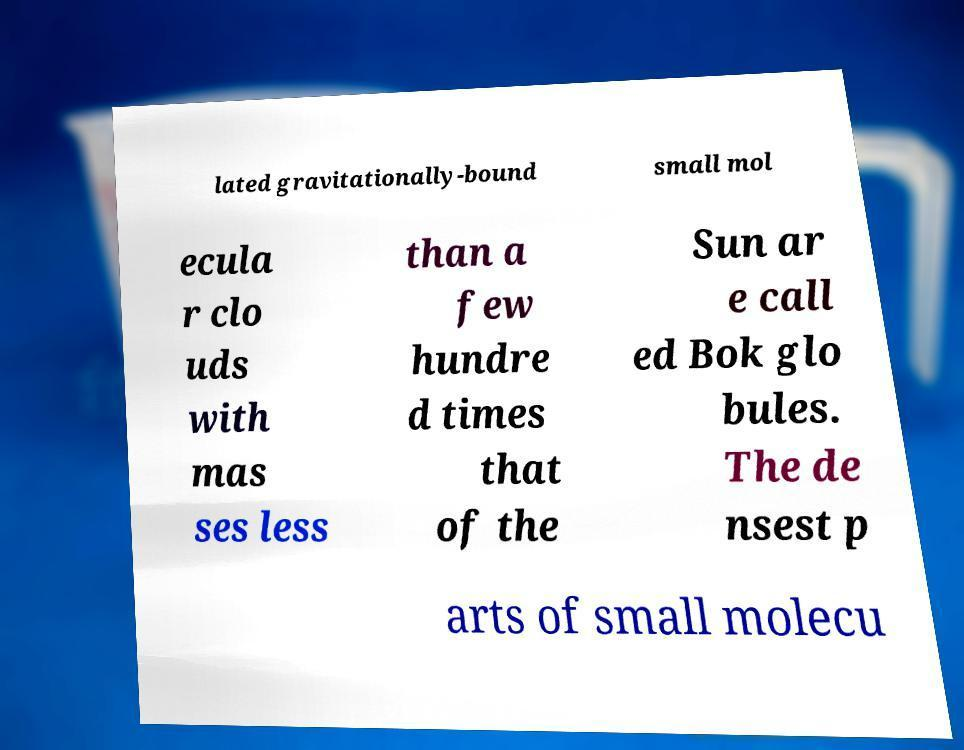Could you assist in decoding the text presented in this image and type it out clearly? lated gravitationally-bound small mol ecula r clo uds with mas ses less than a few hundre d times that of the Sun ar e call ed Bok glo bules. The de nsest p arts of small molecu 